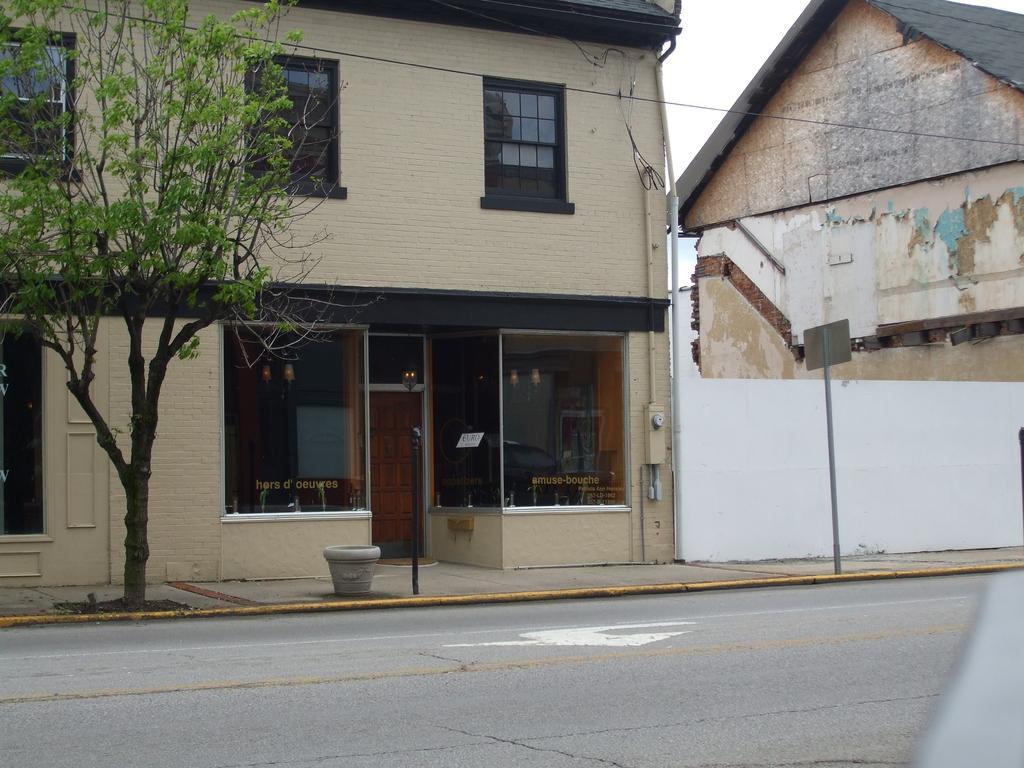Can you describe this image briefly? This picture is clicked outside the city. At the bottom of the picture, we see the road. Beside that, we see a flower pot and a blank white board on the iron pole. Beside that, we see a building which has glass doors and windows. On the left side, we see a tree. On the right side, we see a building with a black color roof. 